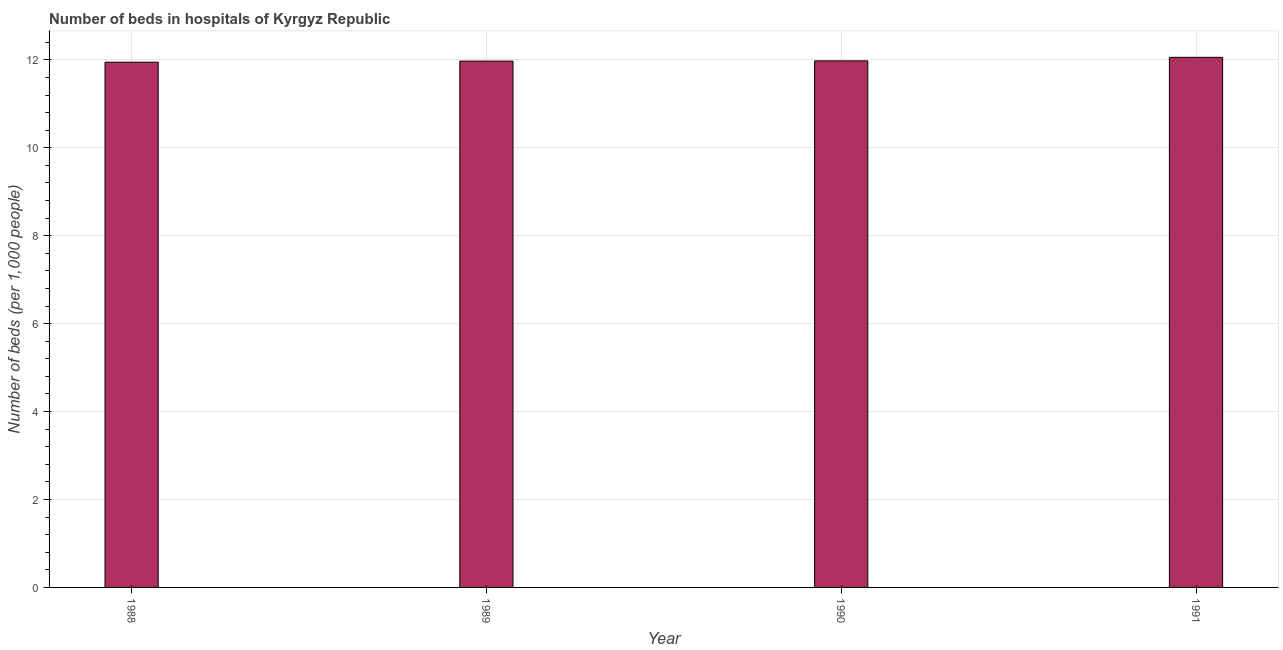Does the graph contain any zero values?
Give a very brief answer. No. What is the title of the graph?
Your answer should be compact. Number of beds in hospitals of Kyrgyz Republic. What is the label or title of the Y-axis?
Provide a succinct answer. Number of beds (per 1,0 people). What is the number of hospital beds in 1988?
Your answer should be very brief. 11.95. Across all years, what is the maximum number of hospital beds?
Offer a very short reply. 12.06. Across all years, what is the minimum number of hospital beds?
Your response must be concise. 11.95. In which year was the number of hospital beds minimum?
Your answer should be very brief. 1988. What is the sum of the number of hospital beds?
Your response must be concise. 47.95. What is the difference between the number of hospital beds in 1988 and 1991?
Offer a terse response. -0.11. What is the average number of hospital beds per year?
Offer a terse response. 11.99. What is the median number of hospital beds?
Your answer should be compact. 11.97. Is the number of hospital beds in 1990 less than that in 1991?
Give a very brief answer. Yes. What is the difference between the highest and the second highest number of hospital beds?
Provide a short and direct response. 0.08. Is the sum of the number of hospital beds in 1988 and 1989 greater than the maximum number of hospital beds across all years?
Your response must be concise. Yes. What is the difference between the highest and the lowest number of hospital beds?
Ensure brevity in your answer.  0.11. What is the difference between two consecutive major ticks on the Y-axis?
Keep it short and to the point. 2. What is the Number of beds (per 1,000 people) of 1988?
Give a very brief answer. 11.95. What is the Number of beds (per 1,000 people) of 1989?
Provide a short and direct response. 11.97. What is the Number of beds (per 1,000 people) in 1990?
Ensure brevity in your answer.  11.98. What is the Number of beds (per 1,000 people) in 1991?
Provide a succinct answer. 12.06. What is the difference between the Number of beds (per 1,000 people) in 1988 and 1989?
Your response must be concise. -0.02. What is the difference between the Number of beds (per 1,000 people) in 1988 and 1990?
Make the answer very short. -0.03. What is the difference between the Number of beds (per 1,000 people) in 1988 and 1991?
Your answer should be compact. -0.11. What is the difference between the Number of beds (per 1,000 people) in 1989 and 1990?
Offer a terse response. -0.01. What is the difference between the Number of beds (per 1,000 people) in 1989 and 1991?
Your response must be concise. -0.09. What is the difference between the Number of beds (per 1,000 people) in 1990 and 1991?
Make the answer very short. -0.08. What is the ratio of the Number of beds (per 1,000 people) in 1988 to that in 1990?
Your response must be concise. 1. What is the ratio of the Number of beds (per 1,000 people) in 1988 to that in 1991?
Offer a very short reply. 0.99. What is the ratio of the Number of beds (per 1,000 people) in 1989 to that in 1991?
Offer a terse response. 0.99. What is the ratio of the Number of beds (per 1,000 people) in 1990 to that in 1991?
Provide a short and direct response. 0.99. 